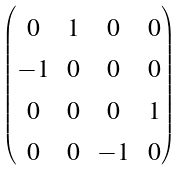<formula> <loc_0><loc_0><loc_500><loc_500>\begin{pmatrix} _ { 0 } & _ { 1 } & _ { 0 } & _ { 0 } \\ _ { - 1 } & _ { 0 } & _ { 0 } & _ { 0 } \\ _ { 0 } & _ { 0 } & _ { 0 } & _ { 1 } \\ _ { 0 } & _ { 0 } & _ { - 1 } & _ { 0 } \end{pmatrix}</formula> 